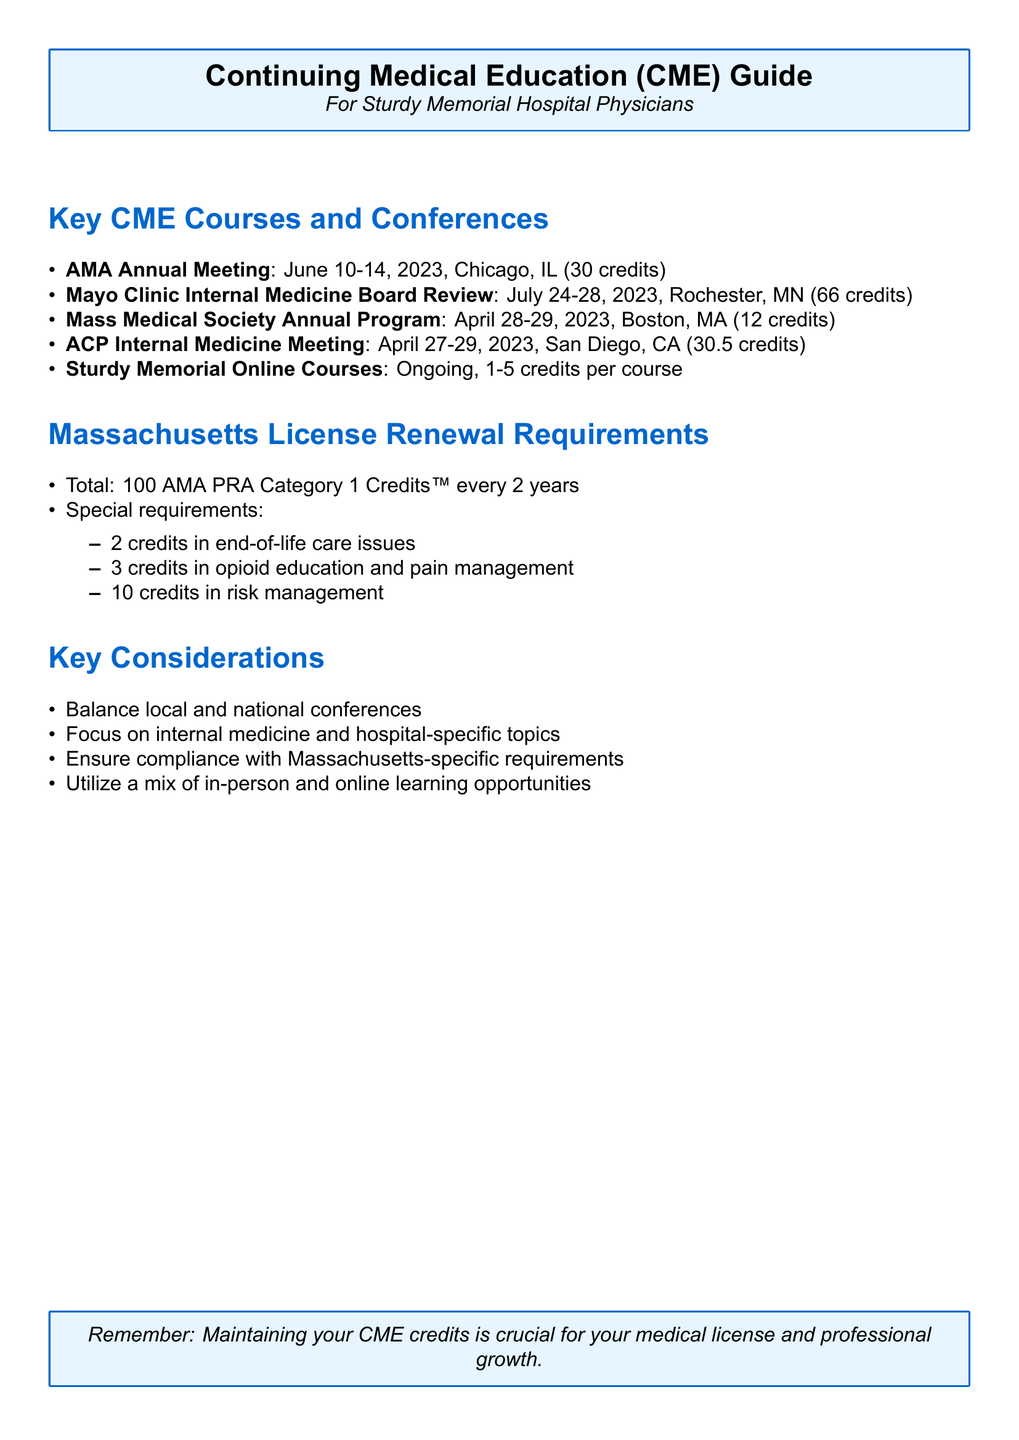What is the date of the AMA Annual Meeting? The document states that the AMA Annual Meeting takes place from June 10-14, 2023.
Answer: June 10-14, 2023 How many credits can be earned from the Mayo Clinic Internal Medicine Board Review? The document indicates that this course offers 66 AMA PRA Category 1 Credits™.
Answer: 66 AMA PRA Category 1 Credits™ What is the location of the Massachusetts Medical Society Annual Education Program? The document specifies that this program is held in Boston, MA.
Answer: Boston, MA What is the total number of credits required for Massachusetts license renewal? The document outlines that a total of 100 AMA PRA Category 1 Credits™ is required.
Answer: 100 AMA PRA Category 1 Credits™ Which CME course has a focus on hospital-specific topics? The document indicates that online courses through Sturdy Memorial Hospital focus on hospital-specific protocols.
Answer: Sturdy Memorial Online Courses How often does the Massachusetts license renewal occur? According to the document, the renewal period is every 2 years.
Answer: Every 2 years What are the special requirements for license renewal related to opioid education? The document specifies that 3 credits in opioid education and pain management are required.
Answer: 3 credits in opioid education and pain management Which conference provides the highest number of credits? The Mayo Clinic Internal Medicine Board Review offers the highest number of credits at 66.
Answer: 66 What is a key consideration for choosing CME courses? The document highlights the importance of balancing local and national conferences as a key consideration.
Answer: Balance local and national conferences 